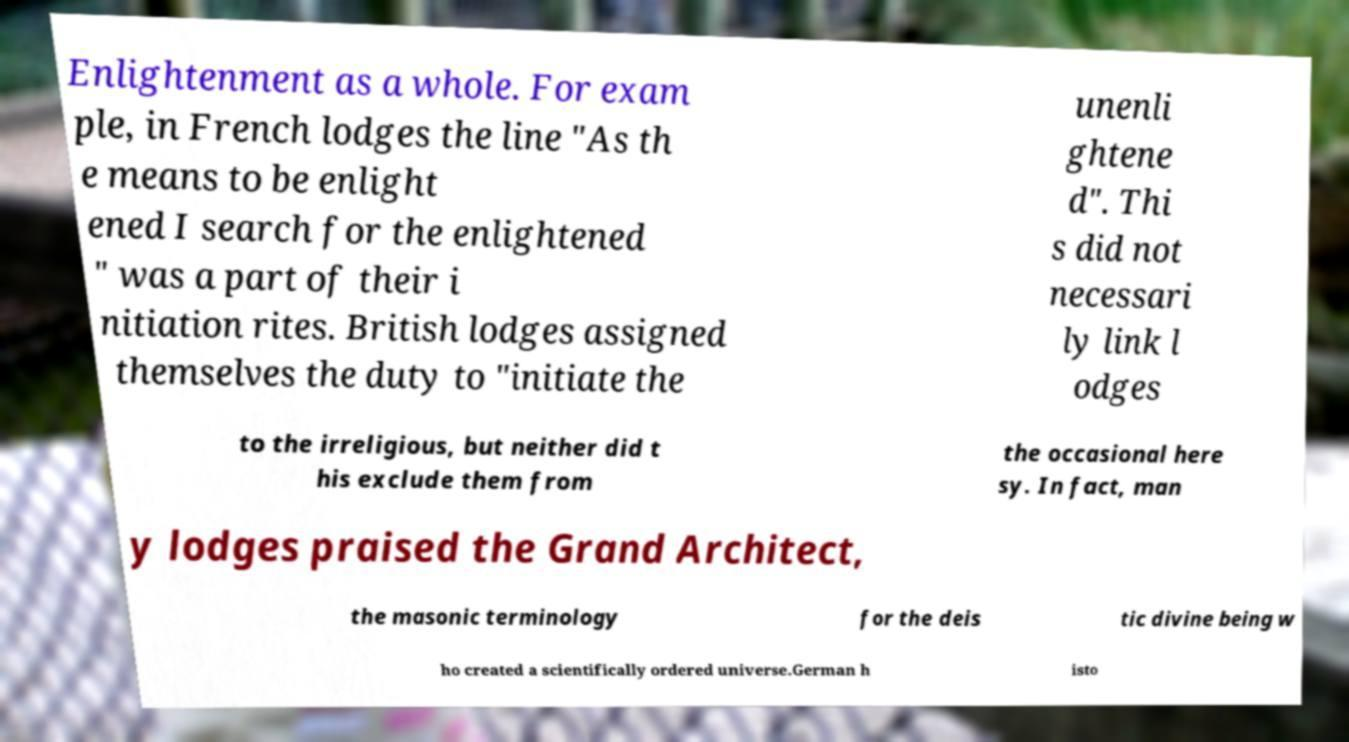What messages or text are displayed in this image? I need them in a readable, typed format. Enlightenment as a whole. For exam ple, in French lodges the line "As th e means to be enlight ened I search for the enlightened " was a part of their i nitiation rites. British lodges assigned themselves the duty to "initiate the unenli ghtene d". Thi s did not necessari ly link l odges to the irreligious, but neither did t his exclude them from the occasional here sy. In fact, man y lodges praised the Grand Architect, the masonic terminology for the deis tic divine being w ho created a scientifically ordered universe.German h isto 